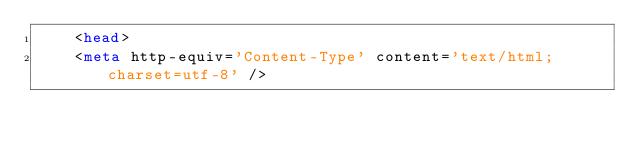<code> <loc_0><loc_0><loc_500><loc_500><_HTML_>		<head>
		<meta http-equiv='Content-Type' content='text/html; charset=utf-8' /></code> 